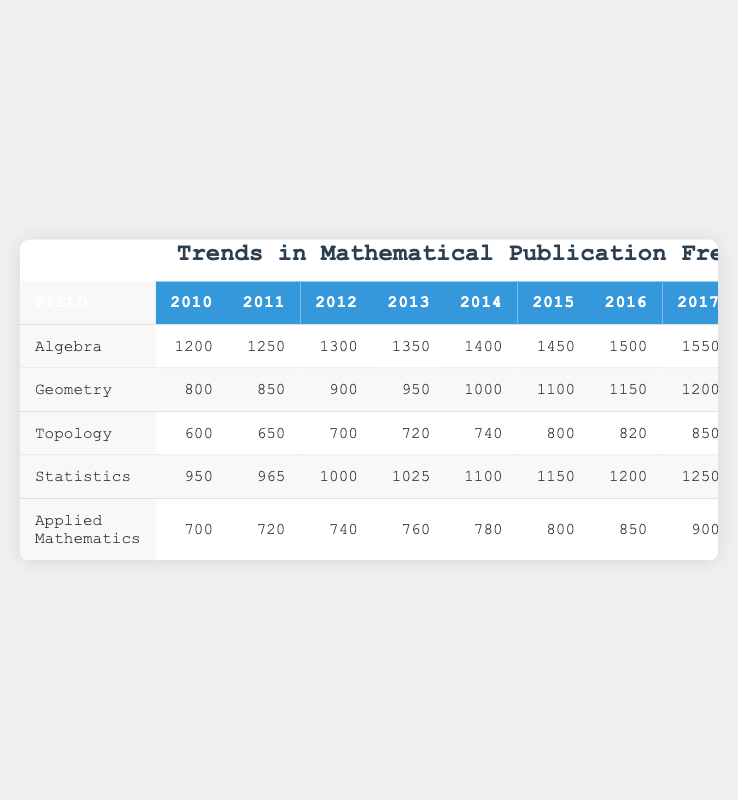What was the number of publications in Algebra in 2020? The table indicates that the number of publications in Algebra for the year 2020 is listed directly under that year, showing a value of 1800.
Answer: 1800 What is the total number of publications in Statistics from 2010 to 2023? To find the total, we sum the publications for all the years listed for Statistics: 950 + 965 + 1000 + 1025 + 1100 + 1150 + 1200 + 1250 + 1300 + 1350 + 1450 + 1500 + 1600 + 1650 = 15,125.
Answer: 15125 Did the number of publications in Topology exceed those in Applied Mathematics in 2021? In 2021, Topology had 1000 publications and Applied Mathematics had 1200 publications, so Topology did not exceed Applied Mathematics.
Answer: No What was the percentage increase in publications from 2010 to 2023 for Geometry? The number of publications in Geometry in 2010 is 800 and in 2023 is 1600. To find the percentage increase, we calculate ((1600 - 800) / 800) * 100 = 100%.
Answer: 100% Which field had the maximum number of publications in 2023? Looking at the table for the year 2023, Algebra had 2100 publications, which is higher than any other field listed.
Answer: Algebra What is the average number of publications in Algebra over the 14 years from 2010 to 2023? To find the average, we sum the number of publications: 1200 + 1250 + 1300 + 1350 + 1400 + 1450 + 1500 + 1550 + 1600 + 1700 + 1800 + 1900 + 2000 + 2100 = 20,300 and divide by the number of years (14), which gives us 20,300 / 14 ≈ 1442.86.
Answer: 1443 Was there a year when the publications in Applied Mathematics surpassed those in Geometry? By comparing the values year by year, Applied Mathematics had more publications than Geometry starting from 2015 to 2023, so there were multiple years where this was true.
Answer: Yes What was the growth trend in the number of publications for the field of Topology during the years 2010 to 2023? The number of publications for Topology increased from 600 in 2010 to 1150 in 2023. The annual growth can be observed with fluctuations, but the overall trend is upward.
Answer: Upward trend 